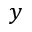Convert formula to latex. <formula><loc_0><loc_0><loc_500><loc_500>y</formula> 